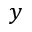Convert formula to latex. <formula><loc_0><loc_0><loc_500><loc_500>y</formula> 